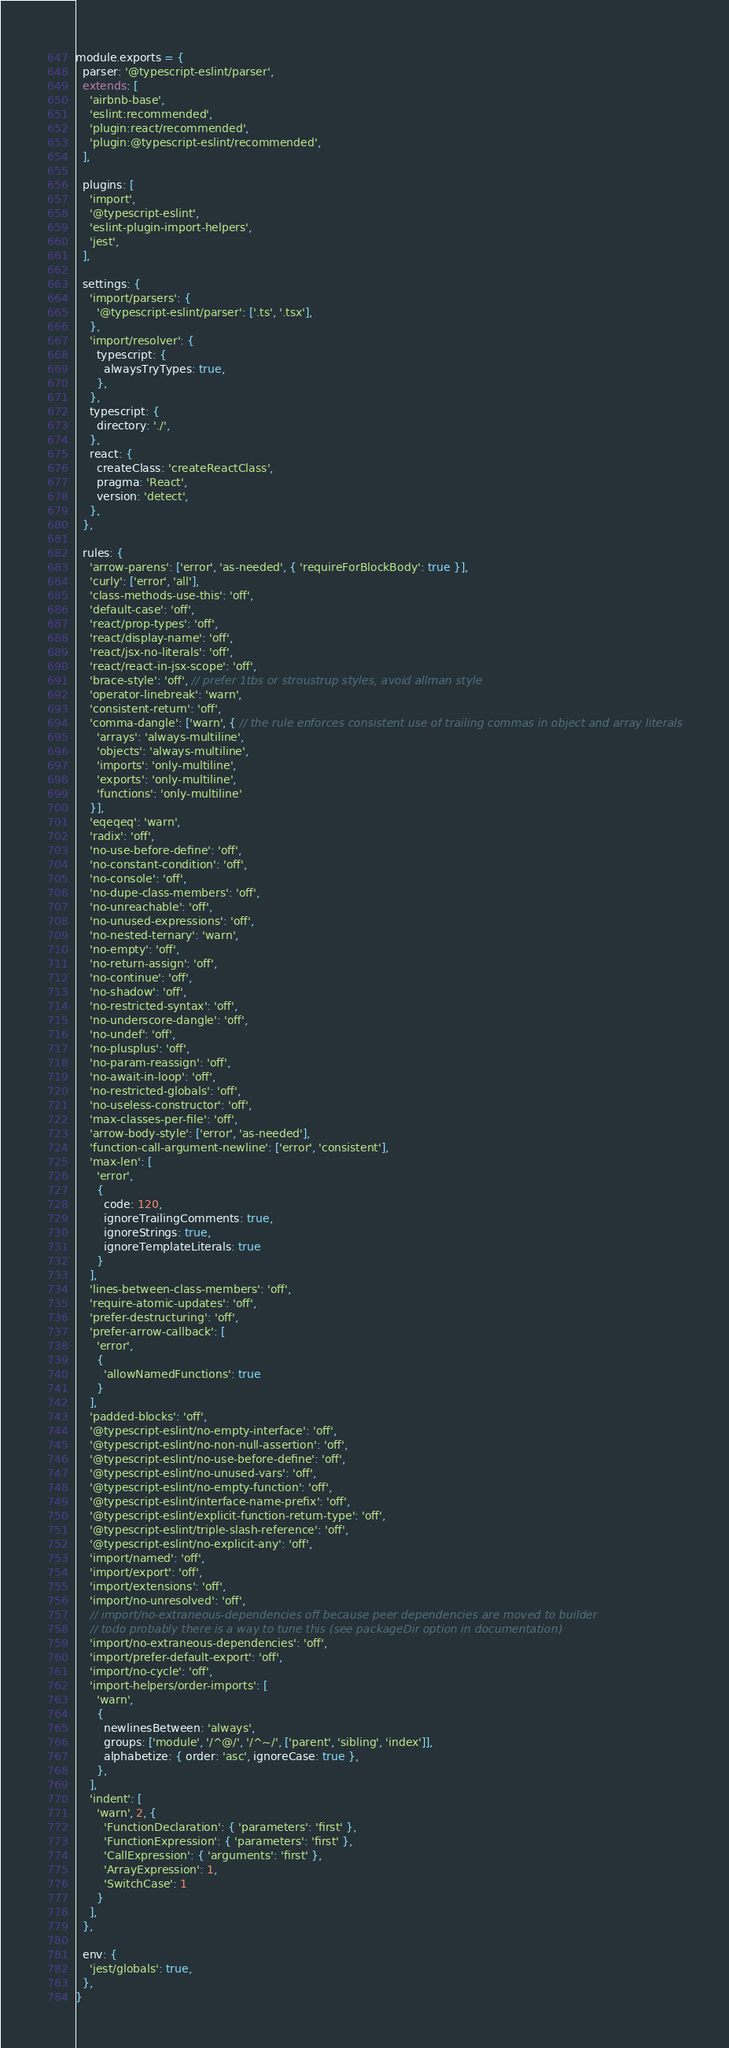<code> <loc_0><loc_0><loc_500><loc_500><_JavaScript_>module.exports = {
  parser: '@typescript-eslint/parser',
  extends: [
    'airbnb-base',
    'eslint:recommended',
    'plugin:react/recommended',
    'plugin:@typescript-eslint/recommended',
  ],

  plugins: [
    'import',
    '@typescript-eslint',
    'eslint-plugin-import-helpers',
    'jest',
  ],

  settings: {
    'import/parsers': {
      '@typescript-eslint/parser': ['.ts', '.tsx'],
    },
    'import/resolver': {
      typescript: {
        alwaysTryTypes: true,
      },
    },
    typescript: {
      directory: './',
    },
    react: {
      createClass: 'createReactClass',
      pragma: 'React',
      version: 'detect',
    },
  },

  rules: {
    'arrow-parens': ['error', 'as-needed', { 'requireForBlockBody': true }],
    'curly': ['error', 'all'],
    'class-methods-use-this': 'off',
    'default-case': 'off',
    'react/prop-types': 'off',
    'react/display-name': 'off',
    'react/jsx-no-literals': 'off',
    'react/react-in-jsx-scope': 'off',
    'brace-style': 'off', // prefer 1tbs or stroustrup styles, avoid allman style
    'operator-linebreak': 'warn',
    'consistent-return': 'off',
    'comma-dangle': ['warn', { // the rule enforces consistent use of trailing commas in object and array literals
      'arrays': 'always-multiline',
      'objects': 'always-multiline',
      'imports': 'only-multiline',
      'exports': 'only-multiline',
      'functions': 'only-multiline'
    }],
    'eqeqeq': 'warn',
    'radix': 'off',
    'no-use-before-define': 'off',
    'no-constant-condition': 'off',
    'no-console': 'off',
    'no-dupe-class-members': 'off',
    'no-unreachable': 'off',
    'no-unused-expressions': 'off',
    'no-nested-ternary': 'warn',
    'no-empty': 'off',
    'no-return-assign': 'off',
    'no-continue': 'off',
    'no-shadow': 'off',
    'no-restricted-syntax': 'off',
    'no-underscore-dangle': 'off',
    'no-undef': 'off',
    'no-plusplus': 'off',
    'no-param-reassign': 'off',
    'no-await-in-loop': 'off',
    'no-restricted-globals': 'off',
    'no-useless-constructor': 'off',
    'max-classes-per-file': 'off',
    'arrow-body-style': ['error', 'as-needed'],
    'function-call-argument-newline': ['error', 'consistent'],
    'max-len': [
      'error',
      {
        code: 120,
        ignoreTrailingComments: true,
        ignoreStrings: true,
        ignoreTemplateLiterals: true
      }
    ],
    'lines-between-class-members': 'off',
    'require-atomic-updates': 'off',
    'prefer-destructuring': 'off',
    'prefer-arrow-callback': [
      'error',
      {
        'allowNamedFunctions': true
      }
    ],
    'padded-blocks': 'off',
    '@typescript-eslint/no-empty-interface': 'off',
    '@typescript-eslint/no-non-null-assertion': 'off',
    '@typescript-eslint/no-use-before-define': 'off',
    '@typescript-eslint/no-unused-vars': 'off',
    '@typescript-eslint/no-empty-function': 'off',
    '@typescript-eslint/interface-name-prefix': 'off',
    '@typescript-eslint/explicit-function-return-type': 'off',
    '@typescript-eslint/triple-slash-reference': 'off',
    '@typescript-eslint/no-explicit-any': 'off',
    'import/named': 'off',
    'import/export': 'off',
    'import/extensions': 'off',
    'import/no-unresolved': 'off',
    // import/no-extraneous-dependencies off because peer dependencies are moved to builder
    // todo probably there is a way to tune this (see packageDir option in documentation)
    'import/no-extraneous-dependencies': 'off',
    'import/prefer-default-export': 'off',
    'import/no-cycle': 'off',
    'import-helpers/order-imports': [
      'warn',
      {
        newlinesBetween: 'always',
        groups: ['module', '/^@/', '/^~/', ['parent', 'sibling', 'index']],
        alphabetize: { order: 'asc', ignoreCase: true },
      },
    ],
    'indent': [
      'warn', 2, {
        'FunctionDeclaration': { 'parameters': 'first' },
        'FunctionExpression': { 'parameters': 'first' },
        'CallExpression': { 'arguments': 'first' },
        'ArrayExpression': 1,
        'SwitchCase': 1
      }
    ],
  },

  env: {
    'jest/globals': true,
  },
}
</code> 